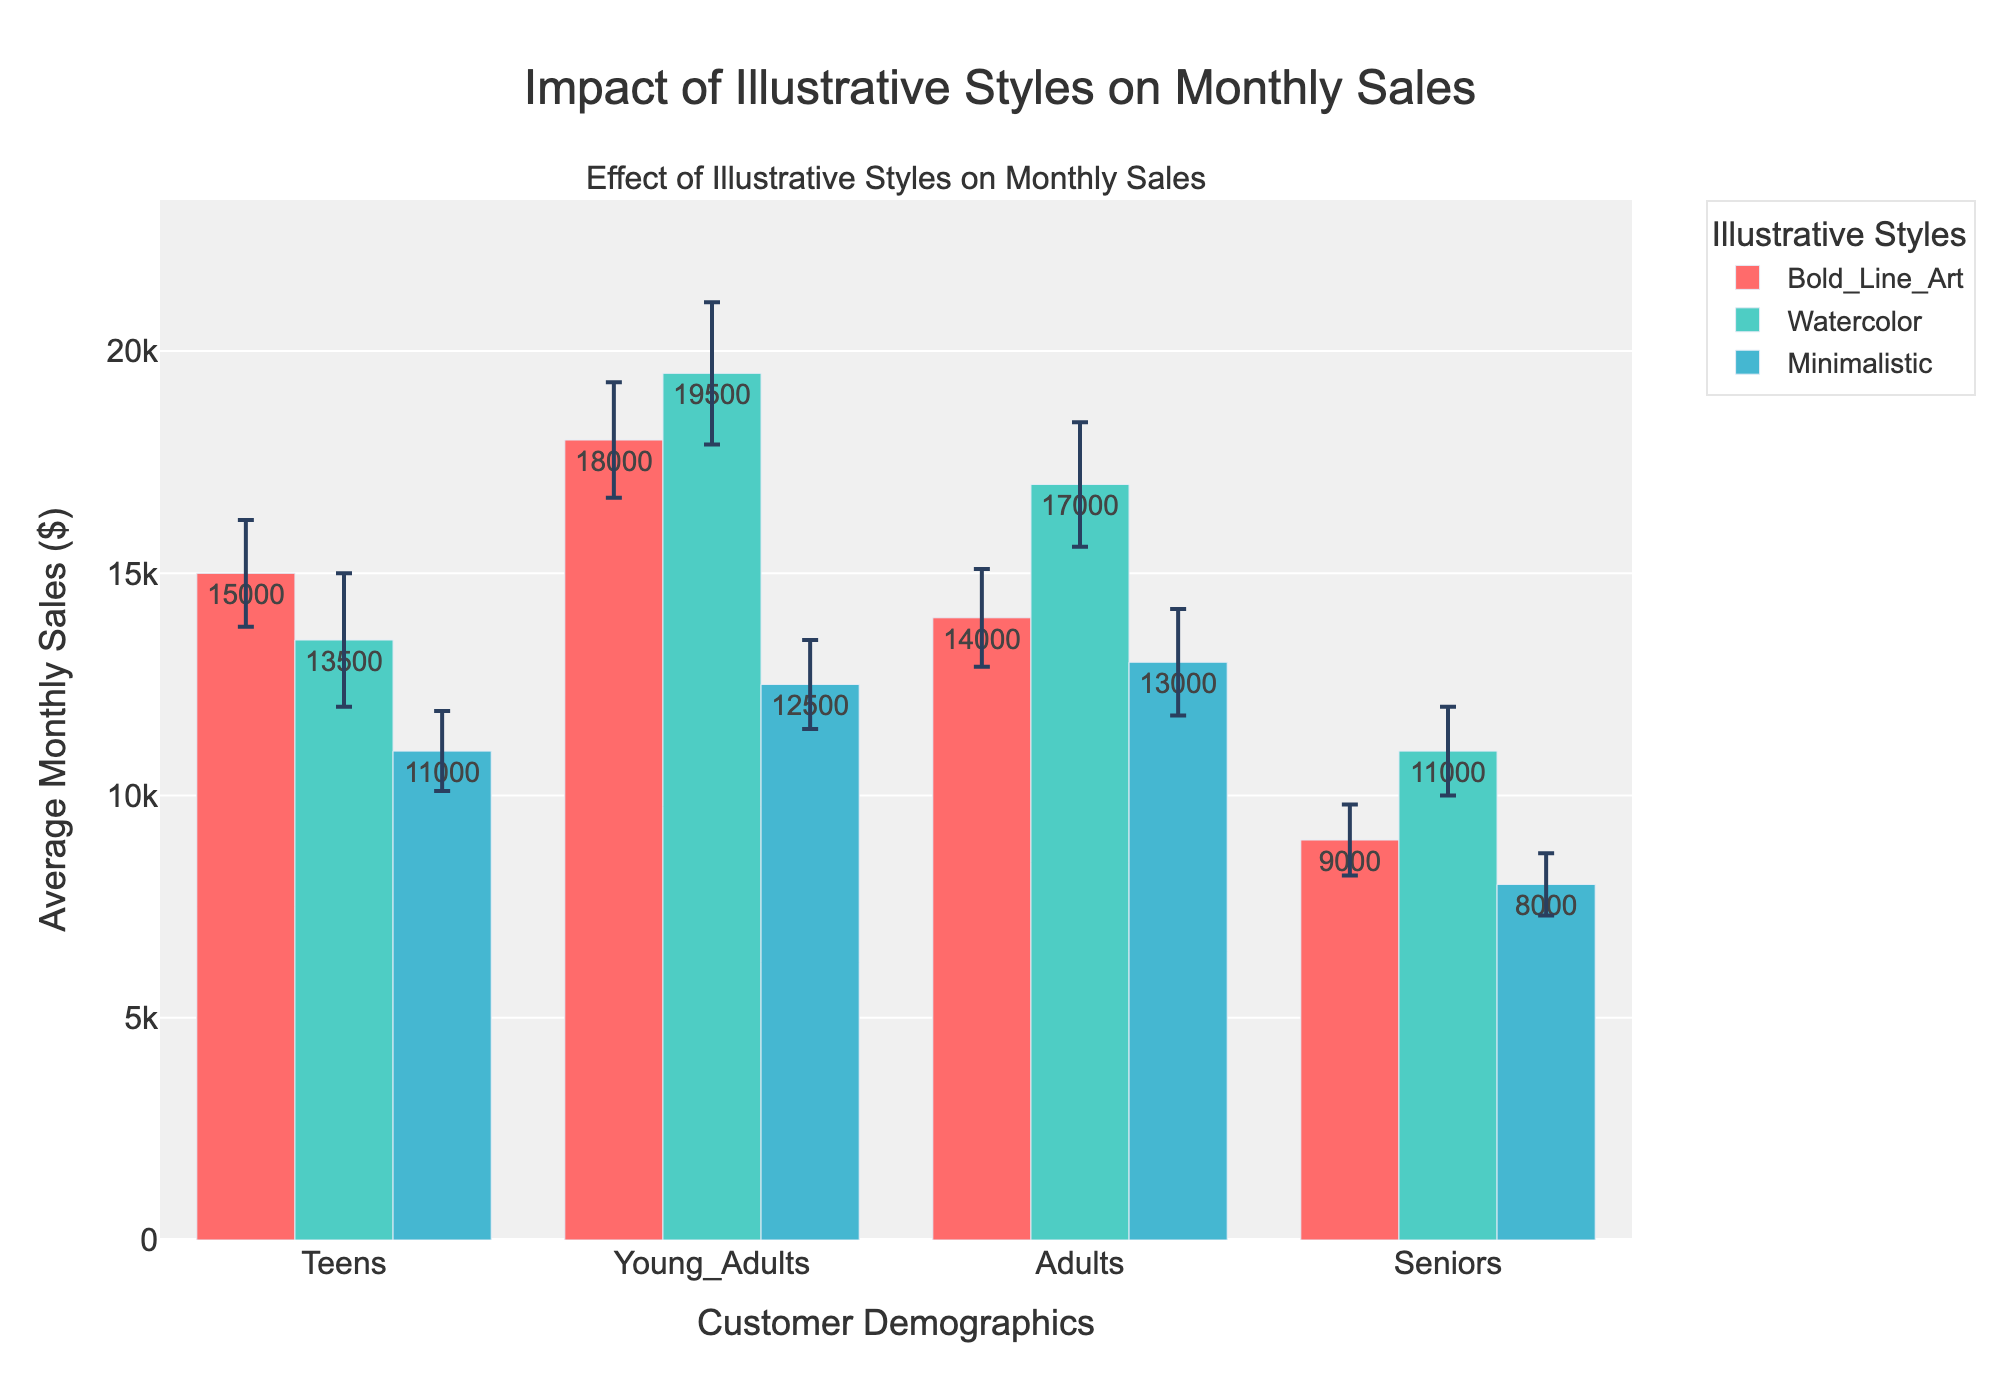What's the title of the plot? The title of the plot is displayed at the top center of the figure.
Answer: Impact of Illustrative Styles on Monthly Sales Which demographic has the highest average monthly sales for Watercolor illustrations? Locate the Watercolor bar for each demographic and compare their heights. Young Adults have the highest bar.
Answer: Young Adults What is the average monthly sale for Bold Line Art in the Adults demographic? Look at the height of the Bold Line Art bar in the Adults demographic section.
Answer: 14000 Which illustrative style shows the least variance in sales for the Teens demographic? Compare the error bars for each illustrative style within the Teens demographic. Minimalistic has the shortest error bar.
Answer: Minimalistic How much higher are the average monthly sales for Young Adults using Watercolor compared to Minimalistic illustrations? Compare the heights of the Watercolor and Minimalistic bars in the Young Adults section. The difference in their heights represents the answer.
Answer: 7000 What is the approximate range of sales (considering variance) for the Bold Line Art style among Seniors? For Seniors, look at the Bold Line Art bar's average sales and add/subtract its variance value. The range is approximately 8200 to 9800.
Answer: 8200 to 9800 Which illustrative style has the most consistent sales performance across all demographics? Identify the style with the shortest error bars across all demographics. Bold Line Art shows the least variability.
Answer: Bold Line Art What is the difference between average monthly sales of Bold Line Art and Minimalistic styles for Teens? Find the height difference between Bold Line Art and Minimalistic bars within the Teens demographic.
Answer: 4000 How does the average monthly sale for Watercolor illustrations compare between Adults and Seniors? Compare the heights of the Watercolor bars in the Adults and Seniors sections. The Adult's bar is taller than the Seniors' bar.
Answer: Adults have higher sales Considering both average sales and variance, which illustrative style would you recommend for maximum reliability in the Teens demographic? Identify the bar with reasonably high average sales and low variance in the Teens demographic. Bold Line Art provides a balance of high sales and low variance.
Answer: Bold Line Art 